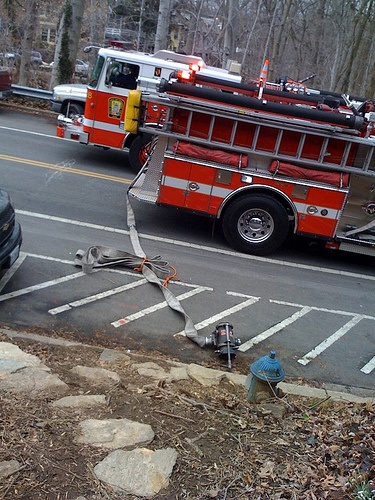Describe the objects in this image and their specific colors. I can see truck in gray, black, and maroon tones, truck in gray, black, brown, and white tones, fire hydrant in gray, black, blue, and teal tones, and car in gray, black, and darkblue tones in this image. 